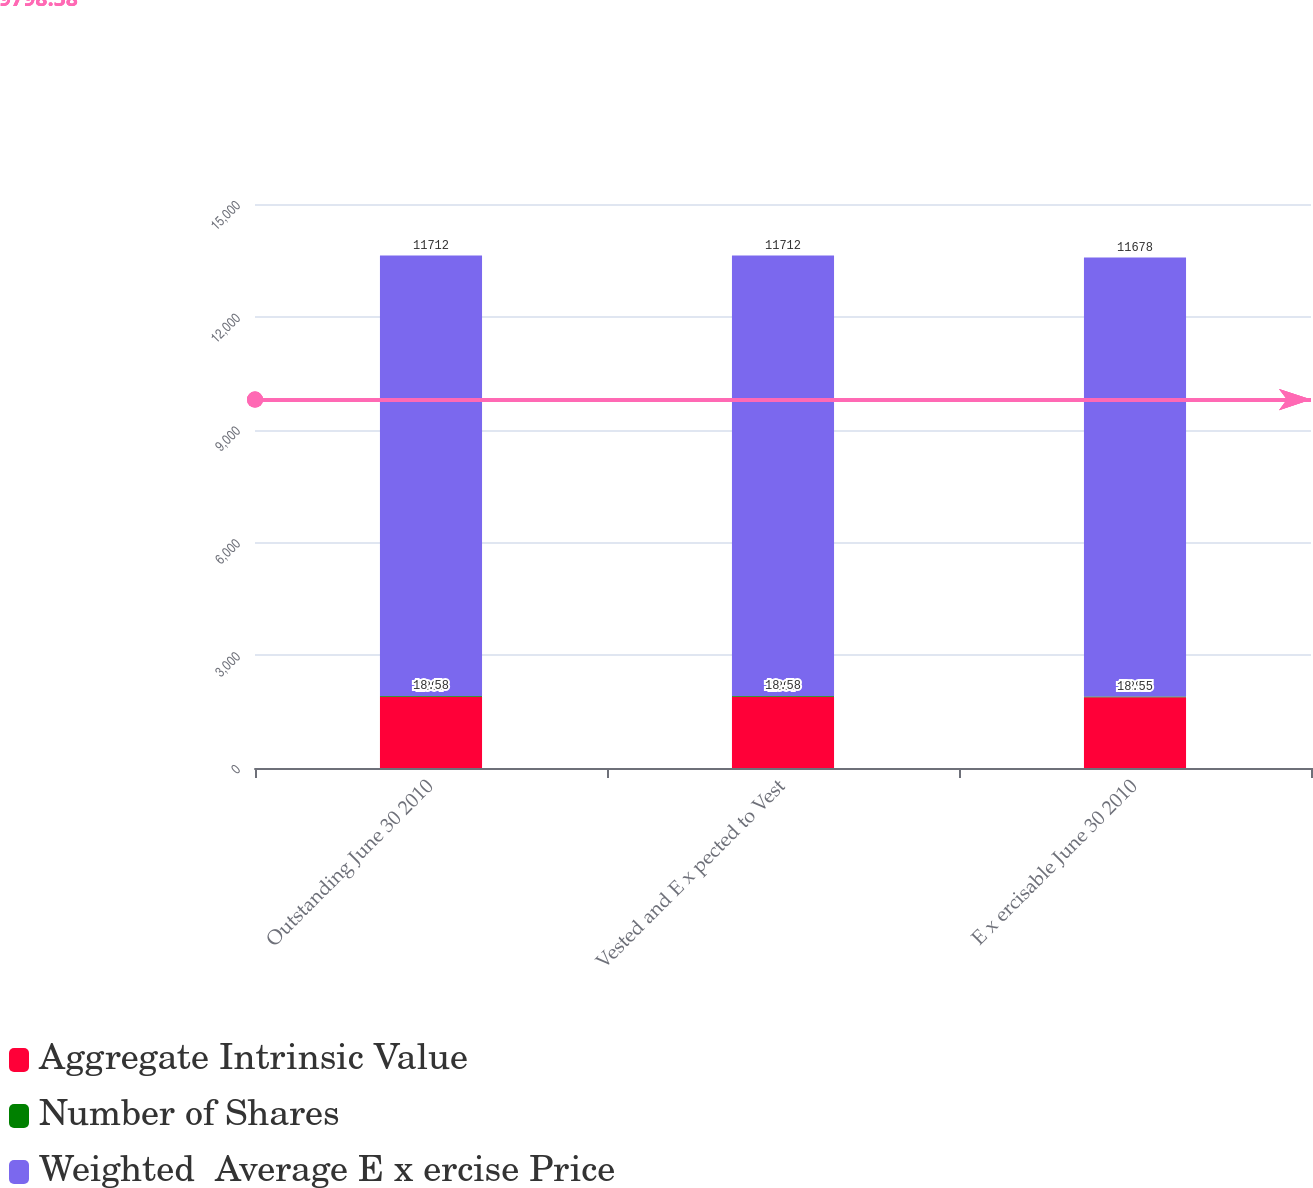Convert chart. <chart><loc_0><loc_0><loc_500><loc_500><stacked_bar_chart><ecel><fcel>Outstanding June 30 2010<fcel>Vested and E x pected to Vest<fcel>E x ercisable June 30 2010<nl><fcel>Aggregate Intrinsic Value<fcel>1897<fcel>1897<fcel>1882<nl><fcel>Number of Shares<fcel>18.58<fcel>18.58<fcel>18.55<nl><fcel>Weighted  Average E x ercise Price<fcel>11712<fcel>11712<fcel>11678<nl></chart> 